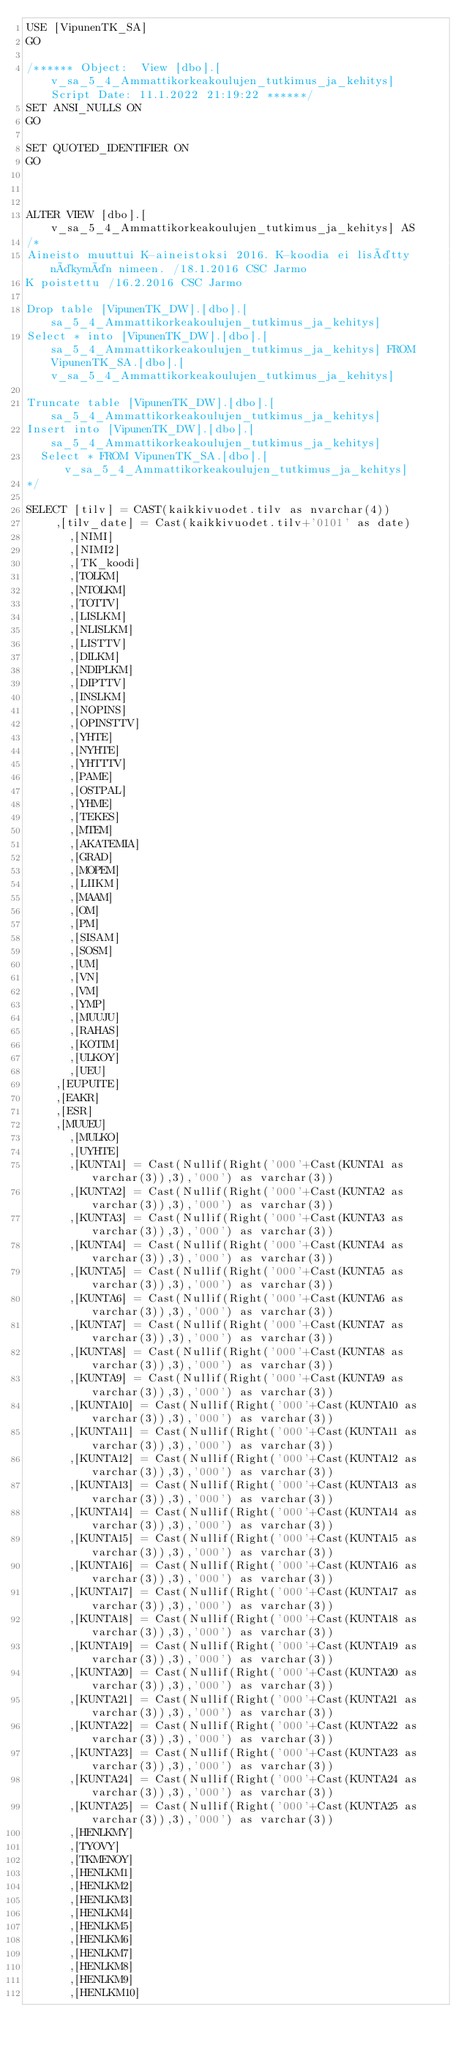<code> <loc_0><loc_0><loc_500><loc_500><_SQL_>USE [VipunenTK_SA]
GO

/****** Object:  View [dbo].[v_sa_5_4_Ammattikorkeakoulujen_tutkimus_ja_kehitys]    Script Date: 11.1.2022 21:19:22 ******/
SET ANSI_NULLS ON
GO

SET QUOTED_IDENTIFIER ON
GO



ALTER VIEW [dbo].[v_sa_5_4_Ammattikorkeakoulujen_tutkimus_ja_kehitys] AS
/*
Aineisto muuttui K-aineistoksi 2016. K-koodia ei lisätty näkymän nimeen. /18.1.2016 CSC Jarmo
K poistettu /16.2.2016 CSC Jarmo

Drop table [VipunenTK_DW].[dbo].[sa_5_4_Ammattikorkeakoulujen_tutkimus_ja_kehitys]
Select * into [VipunenTK_DW].[dbo].[sa_5_4_Ammattikorkeakoulujen_tutkimus_ja_kehitys] FROM VipunenTK_SA.[dbo].[v_sa_5_4_Ammattikorkeakoulujen_tutkimus_ja_kehitys]

Truncate table [VipunenTK_DW].[dbo].[sa_5_4_Ammattikorkeakoulujen_tutkimus_ja_kehitys]
Insert into [VipunenTK_DW].[dbo].[sa_5_4_Ammattikorkeakoulujen_tutkimus_ja_kehitys]
  Select * FROM VipunenTK_SA.[dbo].[v_sa_5_4_Ammattikorkeakoulujen_tutkimus_ja_kehitys]
*/

SELECT [tilv] = CAST(kaikkivuodet.tilv as nvarchar(4))
	  ,[tilv_date] = Cast(kaikkivuodet.tilv+'0101' as date)
      ,[NIMI]
      ,[NIMI2]
      ,[TK_koodi]
      ,[TOLKM]
      ,[NTOLKM]
      ,[TOTTV]
      ,[LISLKM]
      ,[NLISLKM]
      ,[LISTTV]
      ,[DILKM]
      ,[NDIPLKM]
      ,[DIPTTV]
      ,[INSLKM]
      ,[NOPINS]
      ,[OPINSTTV]
      ,[YHTE]
      ,[NYHTE]
      ,[YHTTTV]
      ,[PAME]
      ,[OSTPAL]
      ,[YHME]
      ,[TEKES]
      ,[MTEM]
      ,[AKATEMIA]
      ,[GRAD]
      ,[MOPEM]
      ,[LIIKM]
      ,[MAAM]
      ,[OM]
      ,[PM]
      ,[SISAM]
      ,[SOSM]
      ,[UM]
      ,[VN]
      ,[VM]
      ,[YMP]
      ,[MUUJU]
      ,[RAHAS]
      ,[KOTIM]
      ,[ULKOY]
      ,[UEU]
	  ,[EUPUITE]
	  ,[EAKR]
	  ,[ESR]
	  ,[MUUEU]
      ,[MULKO]
      ,[UYHTE]
      ,[KUNTA1] = Cast(Nullif(Right('000'+Cast(KUNTA1 as varchar(3)),3),'000') as varchar(3))
      ,[KUNTA2] = Cast(Nullif(Right('000'+Cast(KUNTA2 as varchar(3)),3),'000') as varchar(3))
      ,[KUNTA3] = Cast(Nullif(Right('000'+Cast(KUNTA3 as varchar(3)),3),'000') as varchar(3))
      ,[KUNTA4] = Cast(Nullif(Right('000'+Cast(KUNTA4 as varchar(3)),3),'000') as varchar(3))
      ,[KUNTA5] = Cast(Nullif(Right('000'+Cast(KUNTA5 as varchar(3)),3),'000') as varchar(3))
      ,[KUNTA6] = Cast(Nullif(Right('000'+Cast(KUNTA6 as varchar(3)),3),'000') as varchar(3))
      ,[KUNTA7] = Cast(Nullif(Right('000'+Cast(KUNTA7 as varchar(3)),3),'000') as varchar(3))
      ,[KUNTA8] = Cast(Nullif(Right('000'+Cast(KUNTA8 as varchar(3)),3),'000') as varchar(3))
      ,[KUNTA9] = Cast(Nullif(Right('000'+Cast(KUNTA9 as varchar(3)),3),'000') as varchar(3))
      ,[KUNTA10] = Cast(Nullif(Right('000'+Cast(KUNTA10 as varchar(3)),3),'000') as varchar(3))
      ,[KUNTA11] = Cast(Nullif(Right('000'+Cast(KUNTA11 as varchar(3)),3),'000') as varchar(3))
      ,[KUNTA12] = Cast(Nullif(Right('000'+Cast(KUNTA12 as varchar(3)),3),'000') as varchar(3))
      ,[KUNTA13] = Cast(Nullif(Right('000'+Cast(KUNTA13 as varchar(3)),3),'000') as varchar(3))
      ,[KUNTA14] = Cast(Nullif(Right('000'+Cast(KUNTA14 as varchar(3)),3),'000') as varchar(3))
      ,[KUNTA15] = Cast(Nullif(Right('000'+Cast(KUNTA15 as varchar(3)),3),'000') as varchar(3))
      ,[KUNTA16] = Cast(Nullif(Right('000'+Cast(KUNTA16 as varchar(3)),3),'000') as varchar(3))
      ,[KUNTA17] = Cast(Nullif(Right('000'+Cast(KUNTA17 as varchar(3)),3),'000') as varchar(3))
      ,[KUNTA18] = Cast(Nullif(Right('000'+Cast(KUNTA18 as varchar(3)),3),'000') as varchar(3))
      ,[KUNTA19] = Cast(Nullif(Right('000'+Cast(KUNTA19 as varchar(3)),3),'000') as varchar(3))
      ,[KUNTA20] = Cast(Nullif(Right('000'+Cast(KUNTA20 as varchar(3)),3),'000') as varchar(3))
      ,[KUNTA21] = Cast(Nullif(Right('000'+Cast(KUNTA21 as varchar(3)),3),'000') as varchar(3))
      ,[KUNTA22] = Cast(Nullif(Right('000'+Cast(KUNTA22 as varchar(3)),3),'000') as varchar(3))
      ,[KUNTA23] = Cast(Nullif(Right('000'+Cast(KUNTA23 as varchar(3)),3),'000') as varchar(3))
      ,[KUNTA24] = Cast(Nullif(Right('000'+Cast(KUNTA24 as varchar(3)),3),'000') as varchar(3))
      ,[KUNTA25] = Cast(Nullif(Right('000'+Cast(KUNTA25 as varchar(3)),3),'000') as varchar(3))
      ,[HENLKMY]
      ,[TYOVY]
      ,[TKMENOY]
      ,[HENLKM1]
      ,[HENLKM2]
      ,[HENLKM3]
      ,[HENLKM4]
      ,[HENLKM5]
      ,[HENLKM6]
      ,[HENLKM7]
      ,[HENLKM8]
      ,[HENLKM9]
      ,[HENLKM10]</code> 